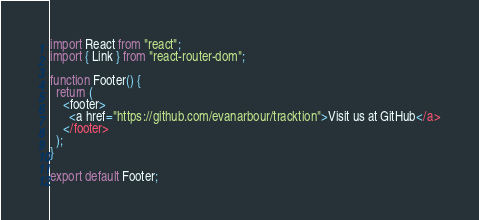<code> <loc_0><loc_0><loc_500><loc_500><_JavaScript_>import React from "react";
import { Link } from "react-router-dom";

function Footer() {
  return (
    <footer>
      <a href="https://github.com/evanarbour/tracktion">Visit us at GitHub</a>
    </footer>
  );
}

export default Footer;
</code> 